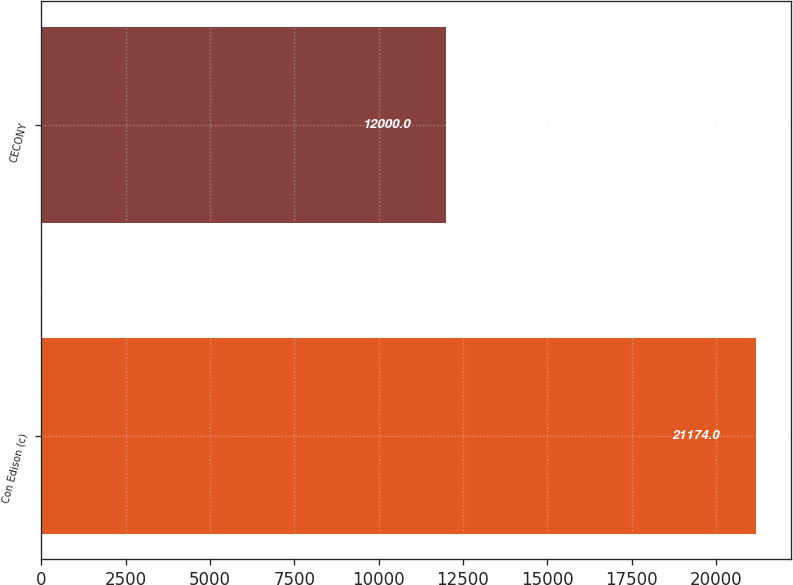Convert chart to OTSL. <chart><loc_0><loc_0><loc_500><loc_500><bar_chart><fcel>Con Edison (c)<fcel>CECONY<nl><fcel>21174<fcel>12000<nl></chart> 